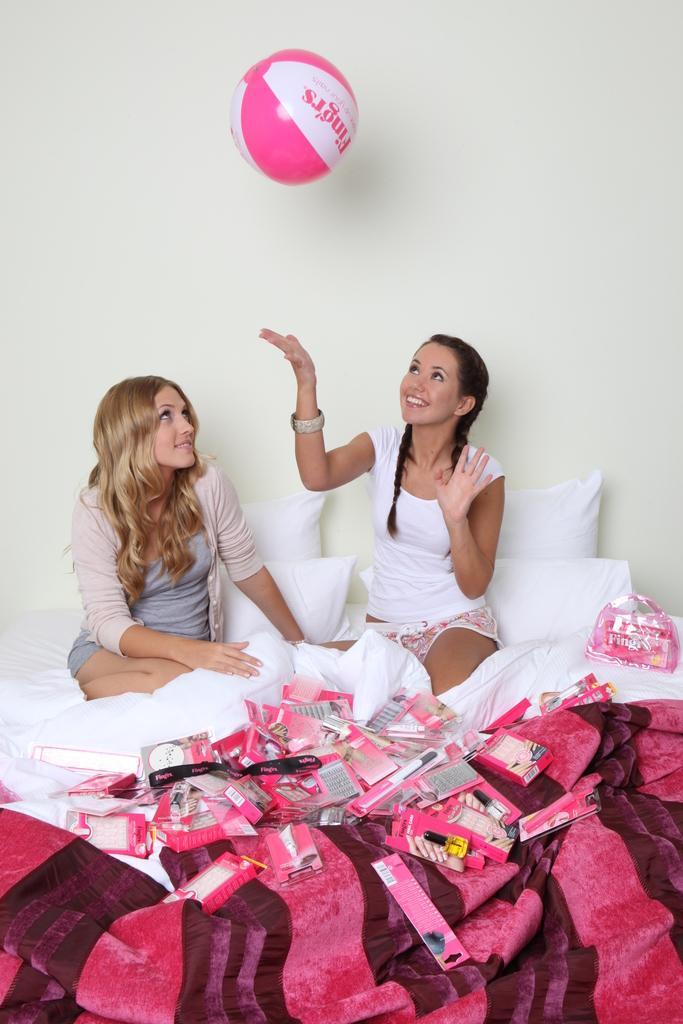In one or two sentences, can you explain what this image depicts? In the image there are two girls sitting on bed with pink bed sheet and white pillows and they are playing with pink ball, behind them its a wall. 